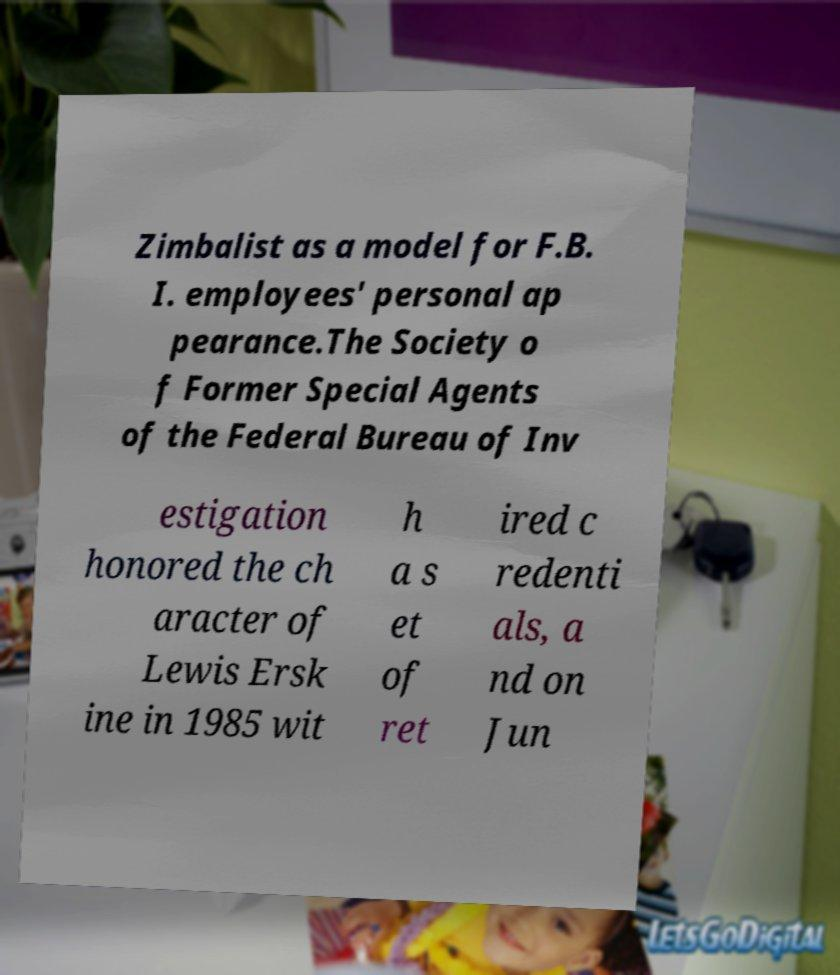What messages or text are displayed in this image? I need them in a readable, typed format. Zimbalist as a model for F.B. I. employees' personal ap pearance.The Society o f Former Special Agents of the Federal Bureau of Inv estigation honored the ch aracter of Lewis Ersk ine in 1985 wit h a s et of ret ired c redenti als, a nd on Jun 